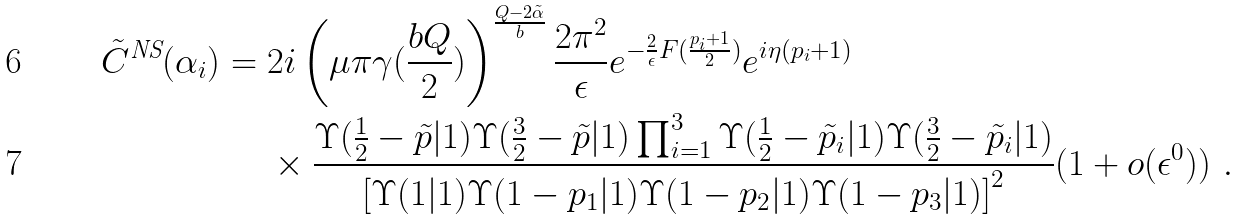<formula> <loc_0><loc_0><loc_500><loc_500>\tilde { C } ^ { \text {NS} } ( \alpha _ { i } ) & = 2 i \left ( \mu \pi \gamma ( \frac { b Q } { 2 } ) \right ) ^ { \frac { Q - 2 \tilde { \alpha } } { b } } \frac { 2 \pi ^ { 2 } } { \epsilon } e ^ { - \frac { 2 } { \epsilon } F ( \frac { p _ { i } + 1 } { 2 } ) } e ^ { i \eta ( p _ { i } + 1 ) } \\ & \quad \ \times \frac { \Upsilon ( \frac { 1 } { 2 } - \tilde { p } | 1 ) \Upsilon ( \frac { 3 } { 2 } - \tilde { p } | 1 ) \prod _ { i = 1 } ^ { 3 } \Upsilon ( \frac { 1 } { 2 } - \tilde { p } _ { i } | 1 ) \Upsilon ( \frac { 3 } { 2 } - \tilde { p } _ { i } | 1 ) } { \left [ \Upsilon ( 1 | 1 ) \Upsilon ( 1 - p _ { 1 } | 1 ) \Upsilon ( 1 - p _ { 2 } | 1 ) \Upsilon ( 1 - p _ { 3 } | 1 ) \right ] ^ { 2 } } ( 1 + o ( \epsilon ^ { 0 } ) ) \ .</formula> 